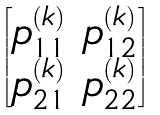Convert formula to latex. <formula><loc_0><loc_0><loc_500><loc_500>\begin{bmatrix} p _ { 1 1 } ^ { ( k ) } & p _ { 1 2 } ^ { ( k ) } \\ p _ { 2 1 } ^ { ( k ) } & p _ { 2 2 } ^ { ( k ) } \end{bmatrix}</formula> 